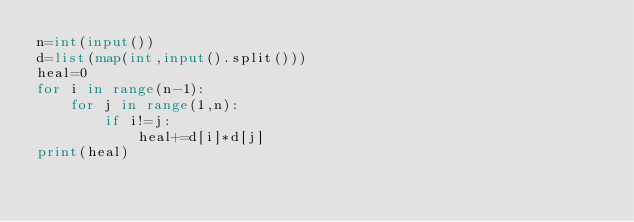Convert code to text. <code><loc_0><loc_0><loc_500><loc_500><_Python_>n=int(input())
d=list(map(int,input().split()))
heal=0
for i in range(n-1):
    for j in range(1,n):
        if i!=j:
            heal+=d[i]*d[j]
print(heal)</code> 